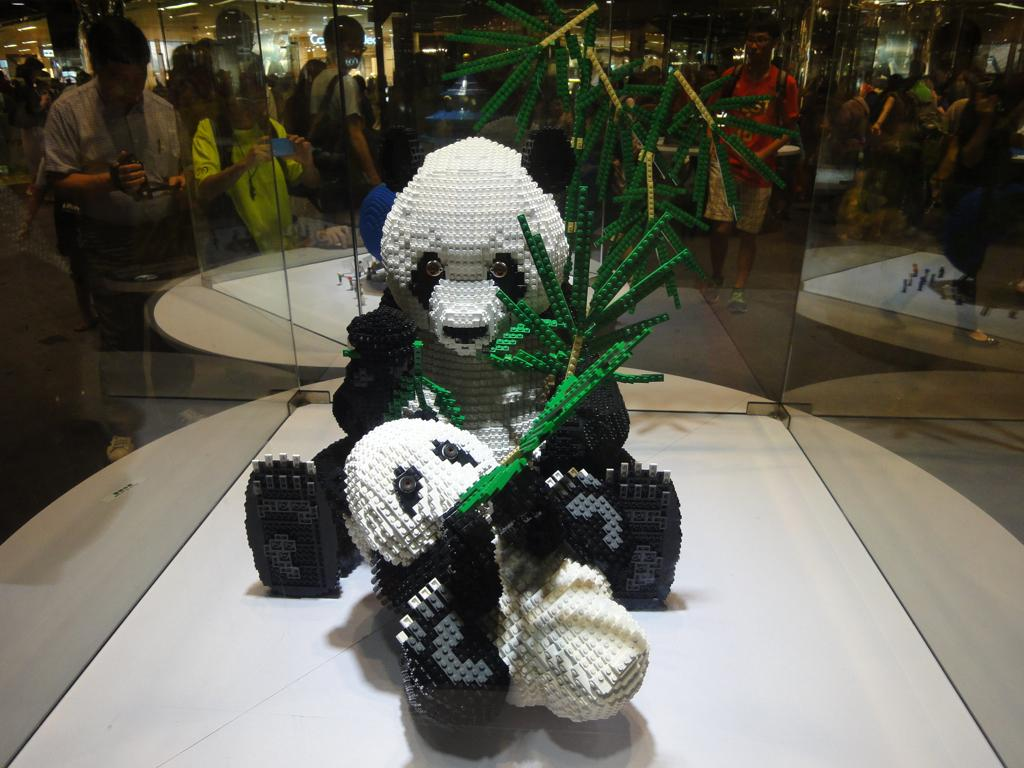What animal is depicted in the image? There is a depiction of a panda in the image. Where is the panda located in the image? The panda is in the middle of the image. What else can be seen in the background of the image? There are people standing in the background of the image. What type of invention is being demonstrated by the panda in the image? There is no invention being demonstrated by the panda in the image; it is simply a depiction of a panda. 